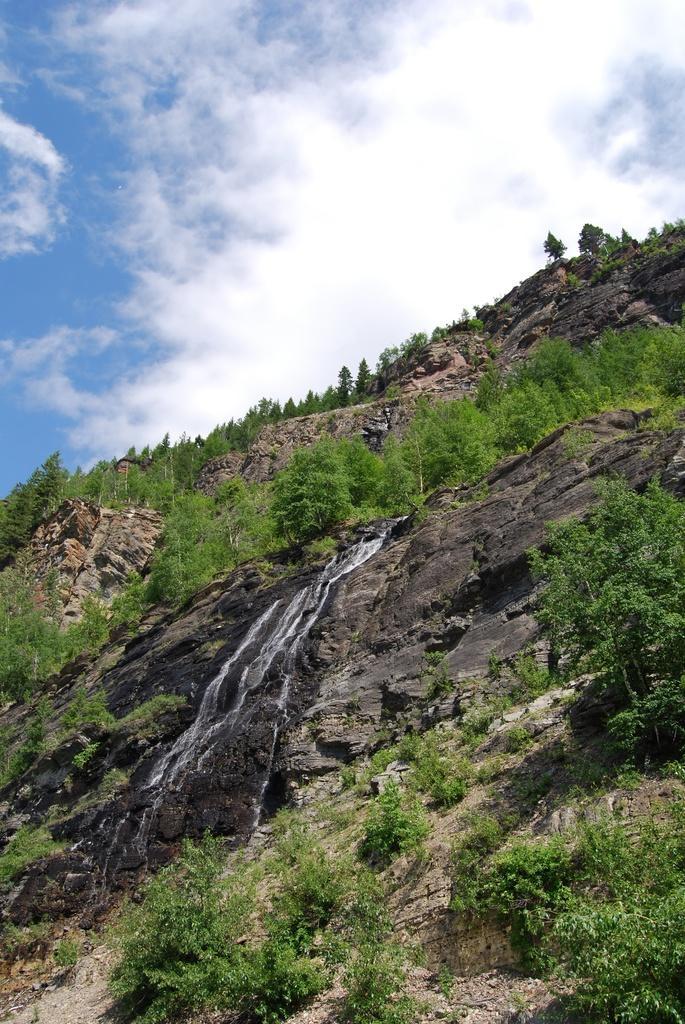Could you give a brief overview of what you see in this image? In this image there are some trees, plants, sand and rocks, and at the top there is sky. 